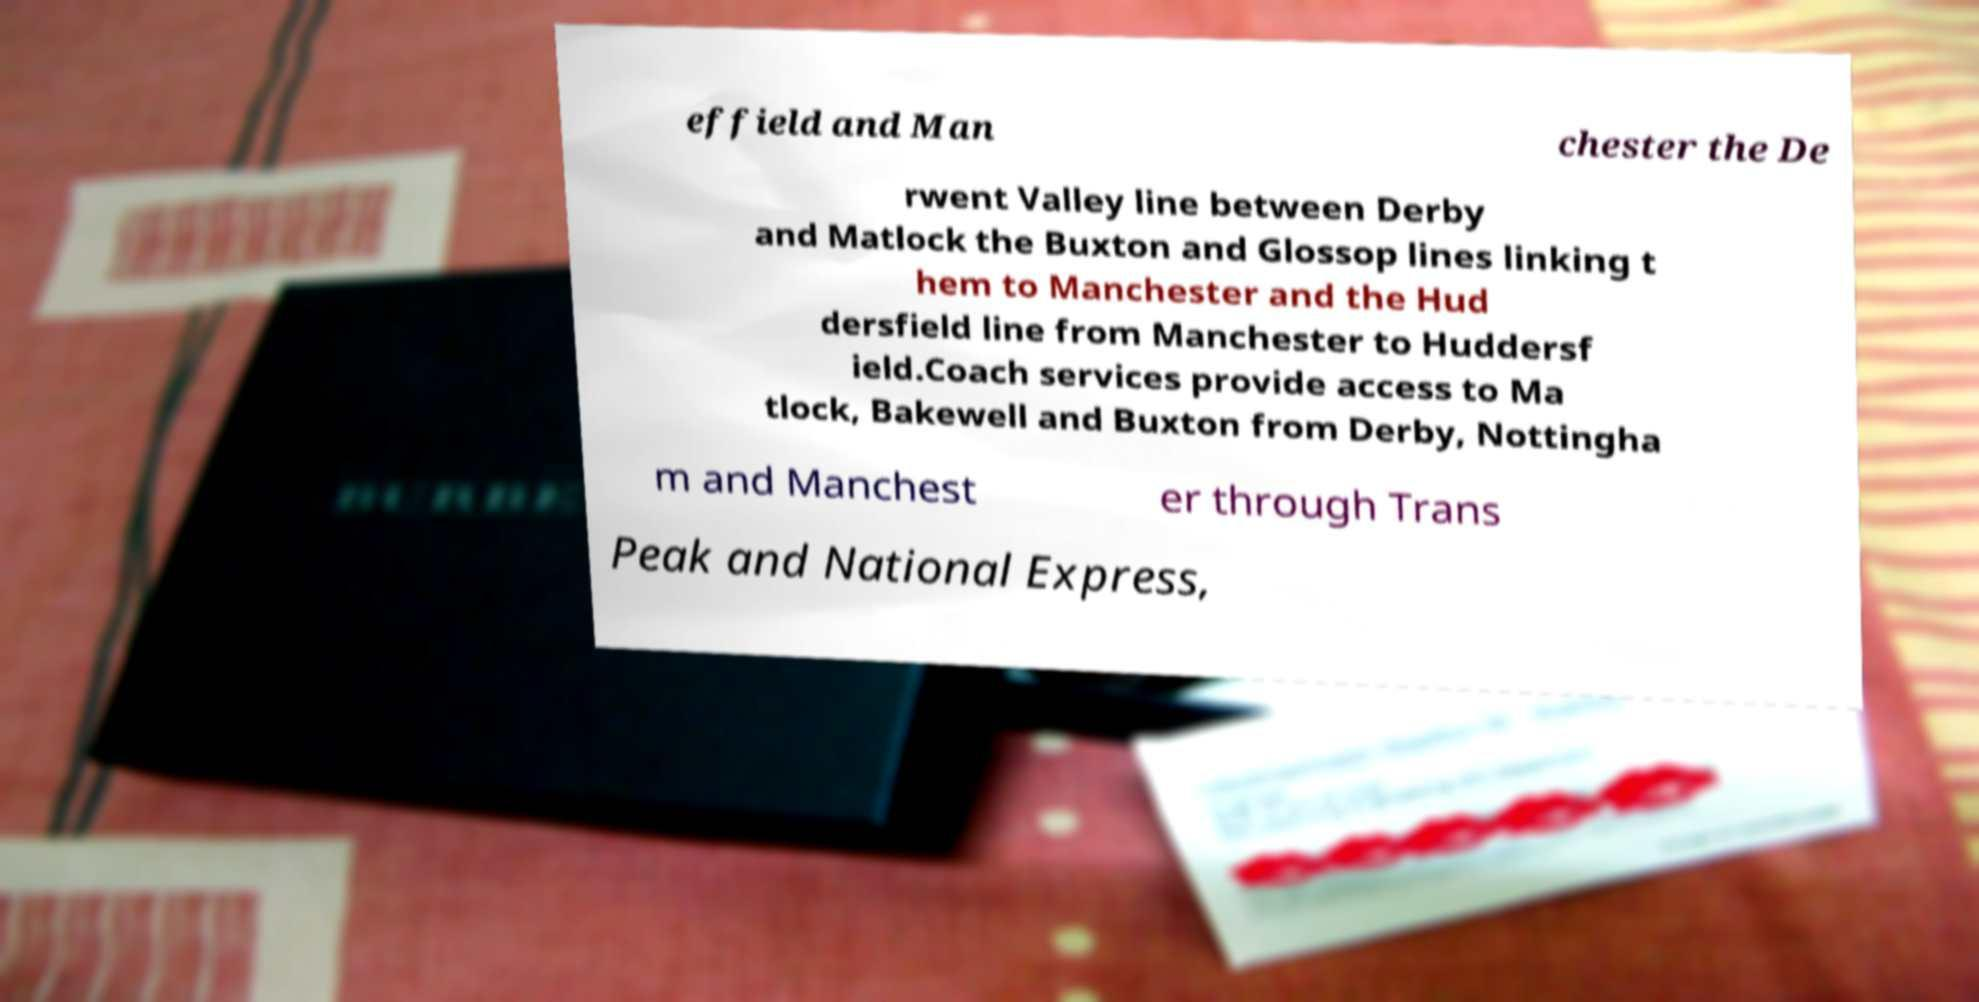Can you accurately transcribe the text from the provided image for me? effield and Man chester the De rwent Valley line between Derby and Matlock the Buxton and Glossop lines linking t hem to Manchester and the Hud dersfield line from Manchester to Huddersf ield.Coach services provide access to Ma tlock, Bakewell and Buxton from Derby, Nottingha m and Manchest er through Trans Peak and National Express, 